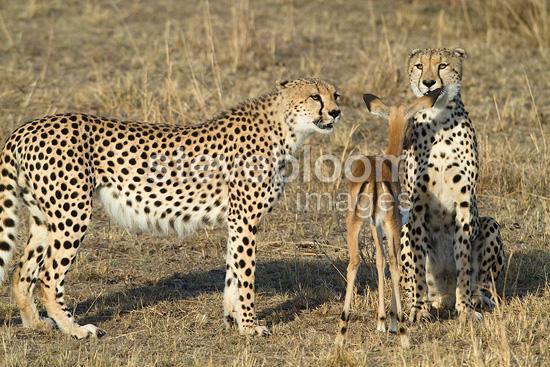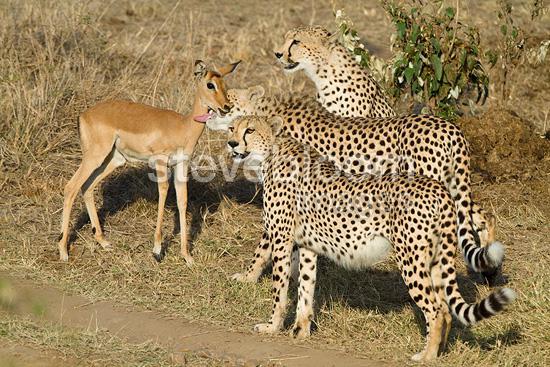The first image is the image on the left, the second image is the image on the right. Examine the images to the left and right. Is the description "There are leopards and at least one deer." accurate? Answer yes or no. Yes. The first image is the image on the left, the second image is the image on the right. Evaluate the accuracy of this statement regarding the images: "In one of the images a cheetah can be seen with meat in its mouth.". Is it true? Answer yes or no. No. 